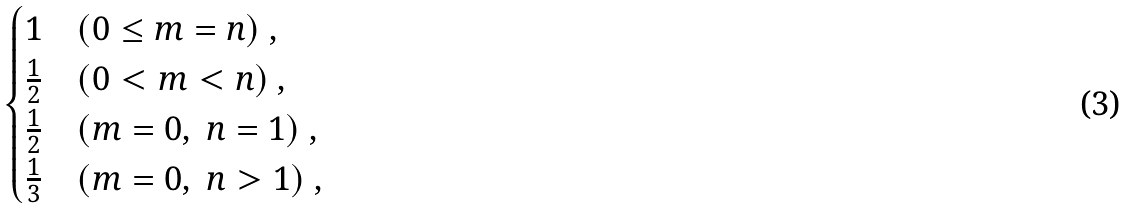<formula> <loc_0><loc_0><loc_500><loc_500>\begin{cases} 1 & ( 0 \leq m = n ) \ , \\ \frac { 1 } { 2 } & ( 0 < m < n ) \ , \\ \frac { 1 } { 2 } & ( m = 0 , \ n = 1 ) \ , \\ \frac { 1 } { 3 } & ( m = 0 , \ n > 1 ) \ , \end{cases}</formula> 